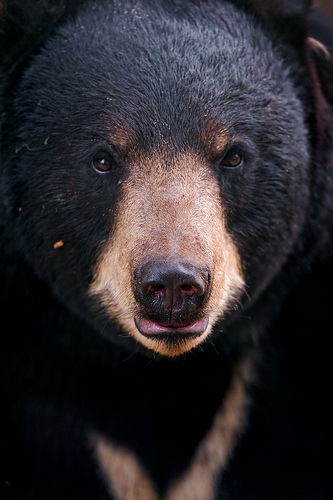Please provide a short description for this region: [0.33, 0.3, 0.4, 0.35]. The coordinates [0.33, 0.3, 0.4, 0.35] highlight a brown eye on the bear. The eye is surrounded by a small amount of tan fur, providing a stark contrast with the dark fur covering most of the face. 